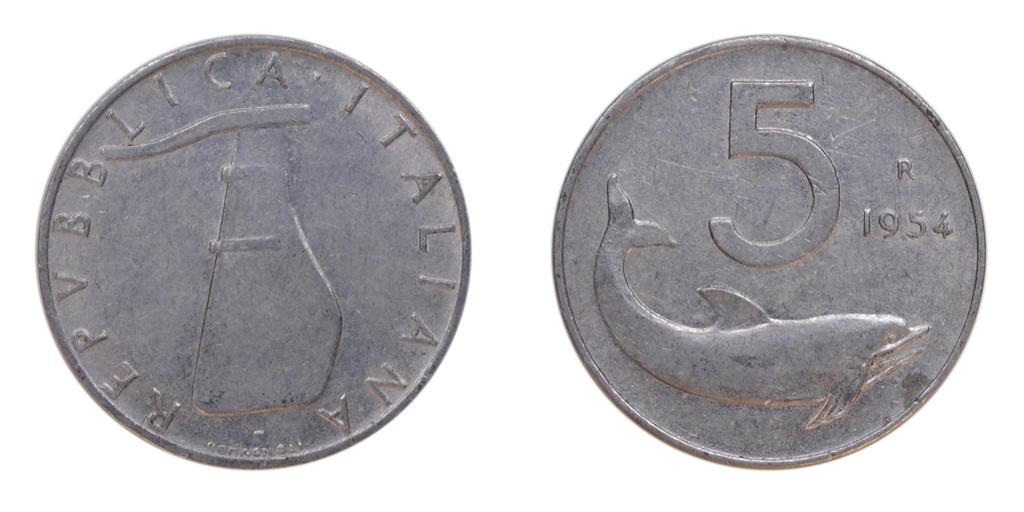What year is on this coin?
Your answer should be compact. 1954. What country is the issuer?
Your answer should be compact. Italy. 